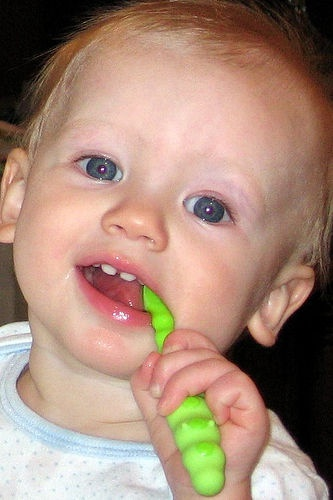Describe the objects in this image and their specific colors. I can see people in tan, black, lightgray, and gray tones and toothbrush in black, lightgreen, lime, and olive tones in this image. 